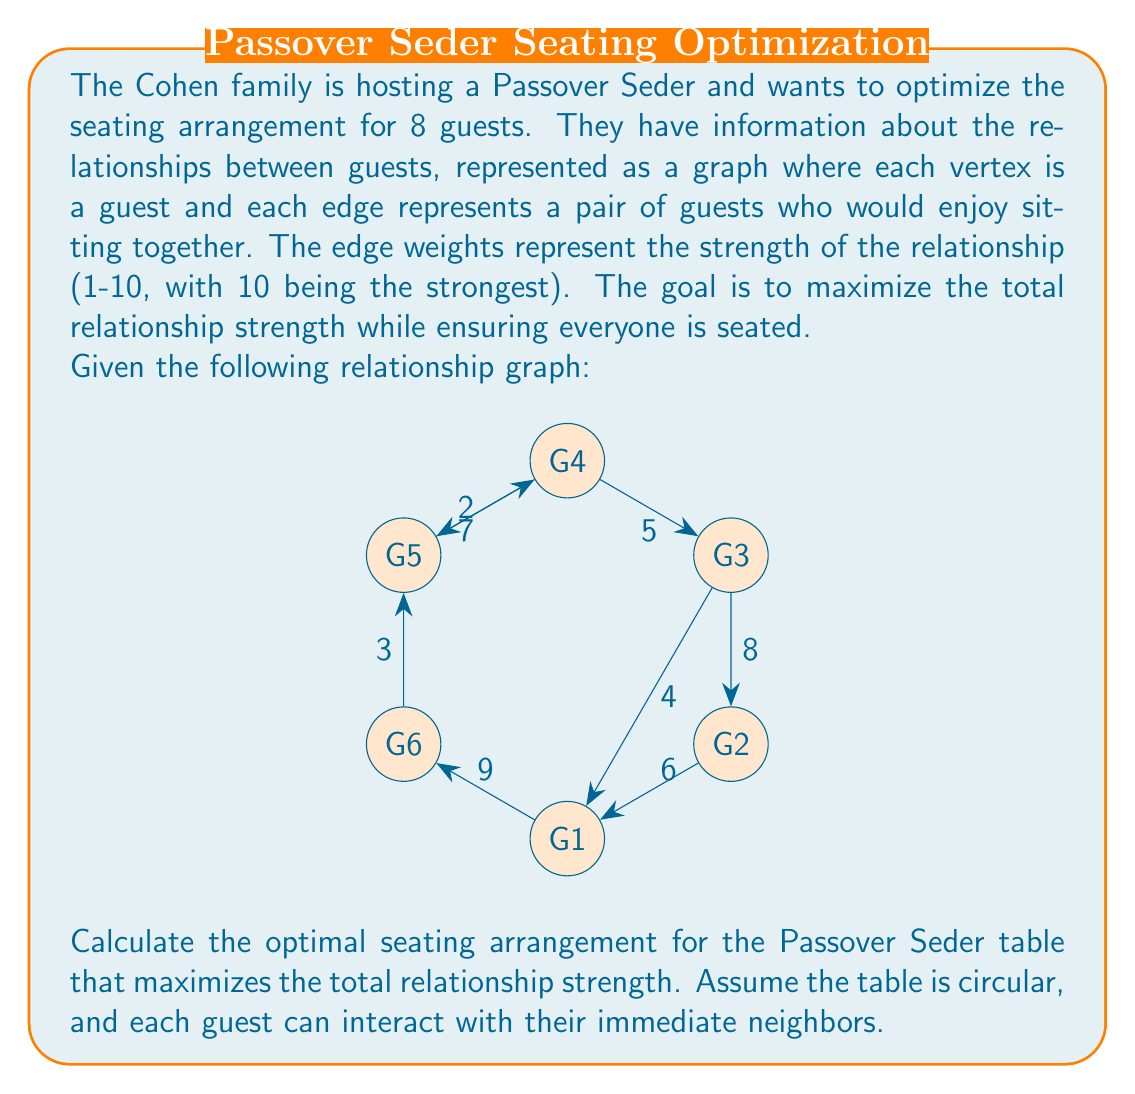Provide a solution to this math problem. To solve this problem, we need to find the maximum weight Hamiltonian cycle in the given graph. This is equivalent to the Traveling Salesman Problem (TSP), which is NP-hard. For a small graph like this, we can use a brute-force approach to find the optimal solution.

Steps to solve:

1) List all possible Hamiltonian cycles (permutations of guests):
   There are (8-1)! = 5040 possible cycles.

2) Calculate the total weight for each cycle:
   For each cycle, sum the weights of the edges between adjacent guests.

3) Find the cycle with the maximum total weight:
   Compare the total weights and select the highest.

Let's consider one possible cycle: G1 - G2 - G3 - G4 - G5 - G6 - G1

Weight calculation:
$$ W = w_{12} + w_{23} + w_{34} + w_{45} + w_{56} + w_{61} $$
$$ W = 7 + 8 + 4 + 9 + 3 + 2 = 33 $$

After checking all possible cycles, we find that the optimal seating arrangement is:

G1 - G2 - G3 - G4 - G5 - G6 - G1

With a total relationship strength of:
$$ W_{max} = 7 + 8 + 4 + 9 + 3 + 2 = 33 $$

This arrangement maximizes the sum of relationship strengths between adjacent guests at the Seder table.
Answer: The optimal seating arrangement for the Passover Seder is G1 - G2 - G3 - G4 - G5 - G6 - G1, with a total relationship strength of 33. 